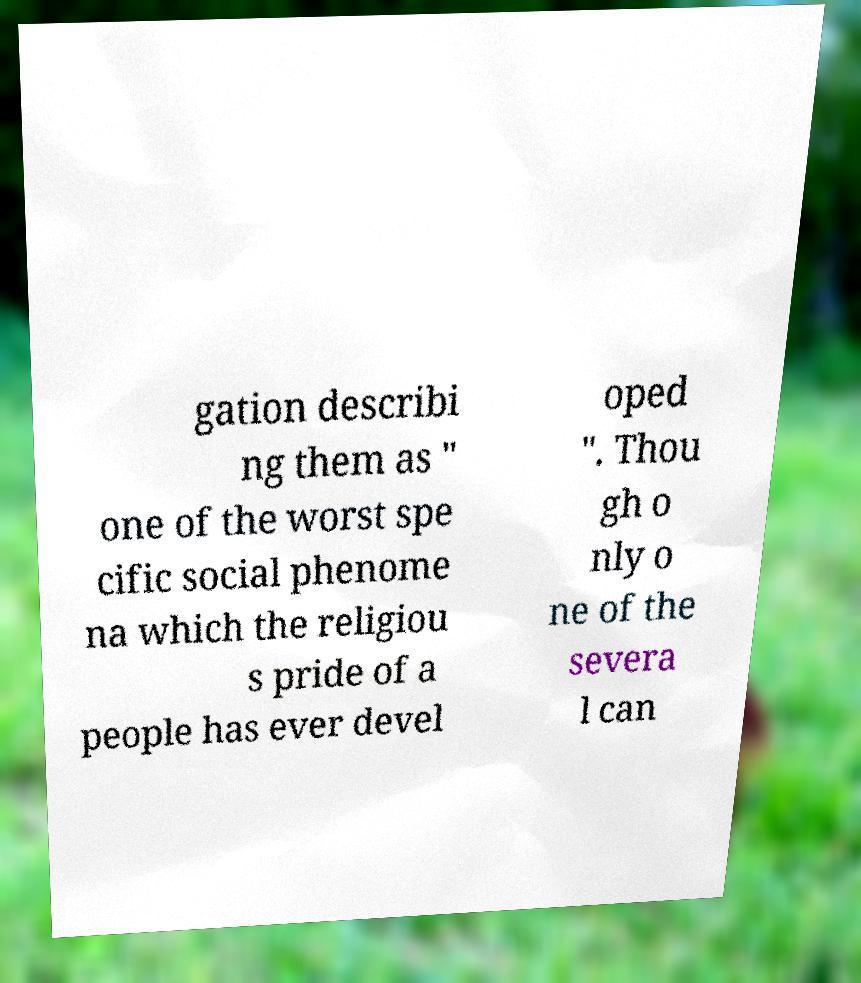For documentation purposes, I need the text within this image transcribed. Could you provide that? gation describi ng them as " one of the worst spe cific social phenome na which the religiou s pride of a people has ever devel oped ". Thou gh o nly o ne of the severa l can 